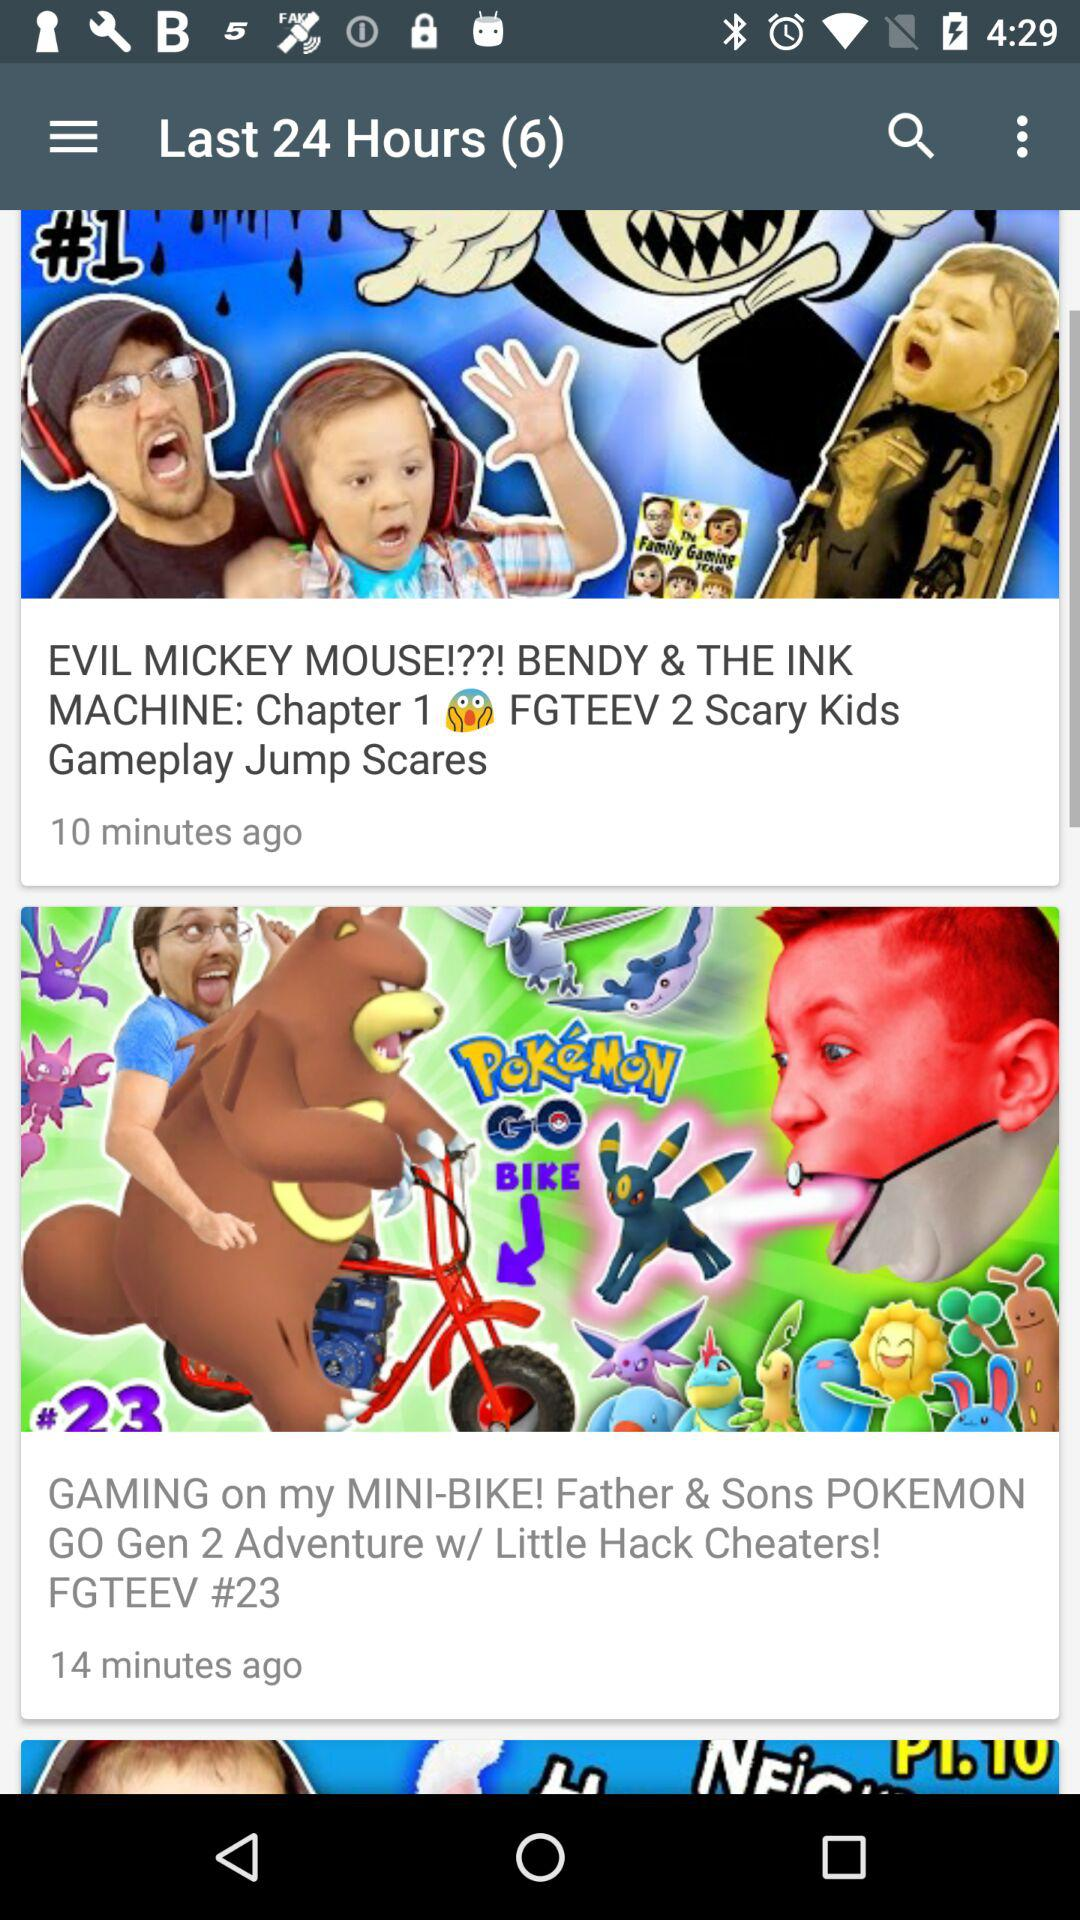What is the name of the game featured in the video that was uploaded 10 minutes ago? The name of the game is "BENDY & THE INK MACHINE". 